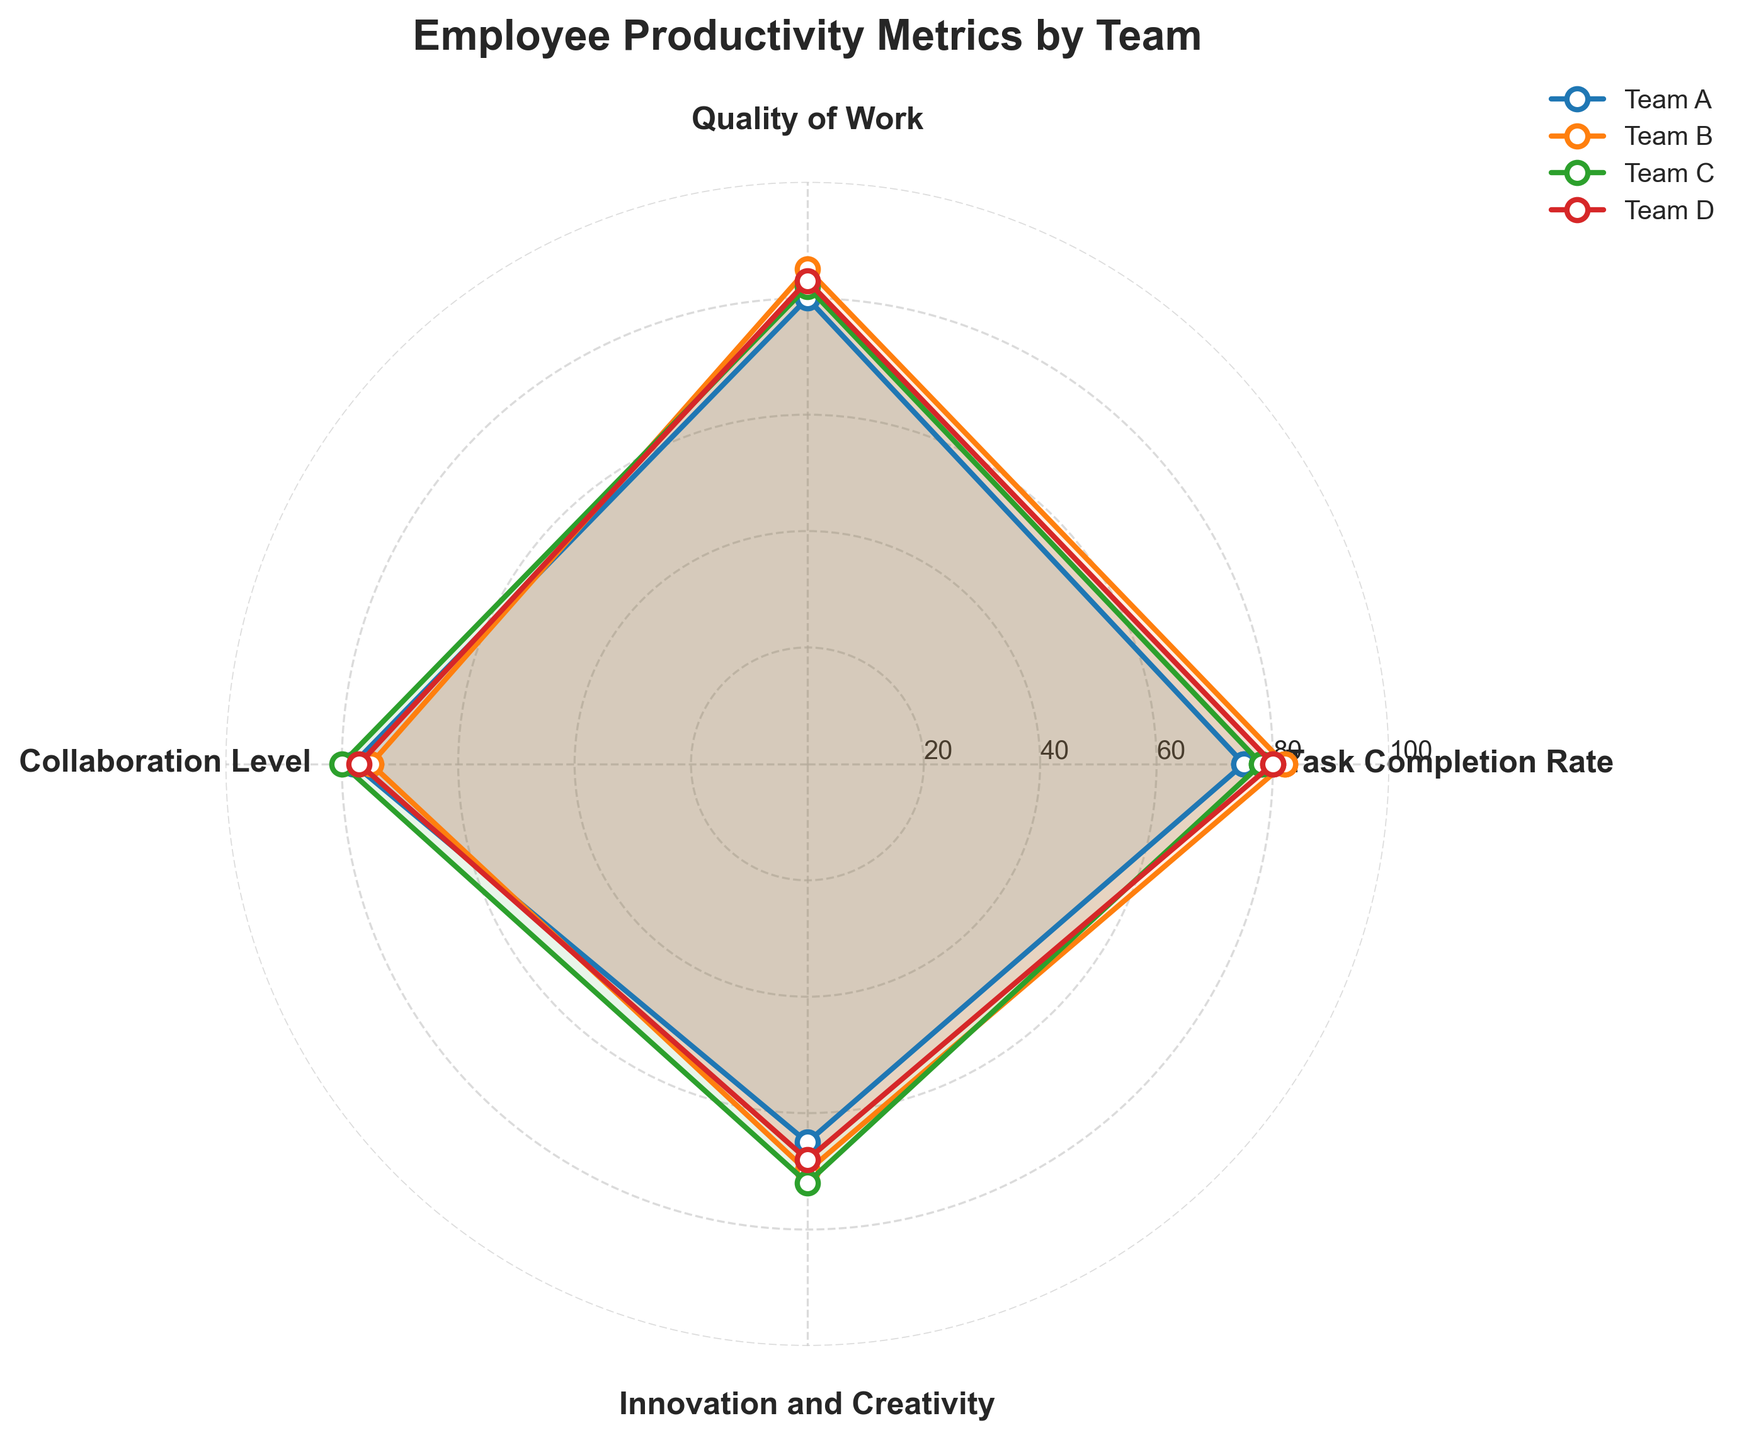What is the title of the figure? The title of the figure is typically positioned at the top and in this case, it reflects the main subject of the figure. The title says "Employee Productivity Metrics by Team".
Answer: Employee Productivity Metrics by Team Which team has the highest Task Completion Rate? Look at the task completion facets of each team's line on the radar chart. Team B has the highest value at 82%.
Answer: Team B Which team has the lowest Innovation and Creativity score? By looking at the Innovation and Creativity axis, you can see which line dips the lowest. Team A has the lowest score at 65%.
Answer: Team A What is the average Quality of Work score among all teams? Add all Quality of Work scores: (80 + 85 + 82 + 83). There are 4 teams, so divide the sum by 4. The average is (80 + 85 + 82 + 83) / 4 = 82.5.
Answer: 82.5 Which two teams have the closest Collaboration Level scores? Observe the Collaboration Level axis. Team A has a score of 78, Team B 75, Team C 80, and Team D 77. The closest are Team A and Team D which differ by 1 point.
Answer: Team A and Team D By how much does Team B exceed Team D in Quality of Work score? Compare the Quality of Work scores: Team B has 85, and Team D has 83. The difference is 85 - 83 = 2.
Answer: 2 Which team shows the most balanced performance across all metrics? The team whose outline has the least variability usually indicates the most balanced performance. Team C appears to have the most even spread around the radar plot, with scores all near 80.
Answer: Team C What is the range of the Task Completion Rate scores among all teams? The range is calculated as the difference between the highest and lowest scores on the Task Completion Rate axis. The highest is 82 (Team B) and the lowest is 75 (Team A), so the range is 82 - 75 = 7.
Answer: 7 